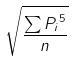Convert formula to latex. <formula><loc_0><loc_0><loc_500><loc_500>\sqrt { \frac { \sum { P _ { i } } ^ { 5 } } { n } }</formula> 